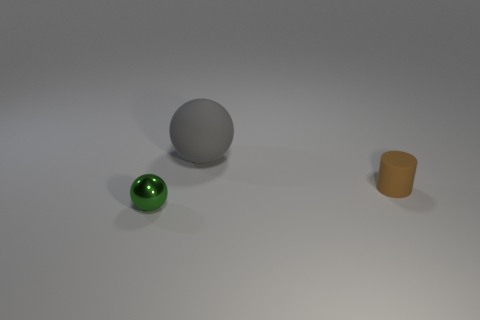Add 3 green objects. How many objects exist? 6 Subtract all spheres. How many objects are left? 1 Subtract all big gray things. Subtract all small green shiny objects. How many objects are left? 1 Add 1 tiny brown cylinders. How many tiny brown cylinders are left? 2 Add 2 rubber objects. How many rubber objects exist? 4 Subtract 0 red blocks. How many objects are left? 3 